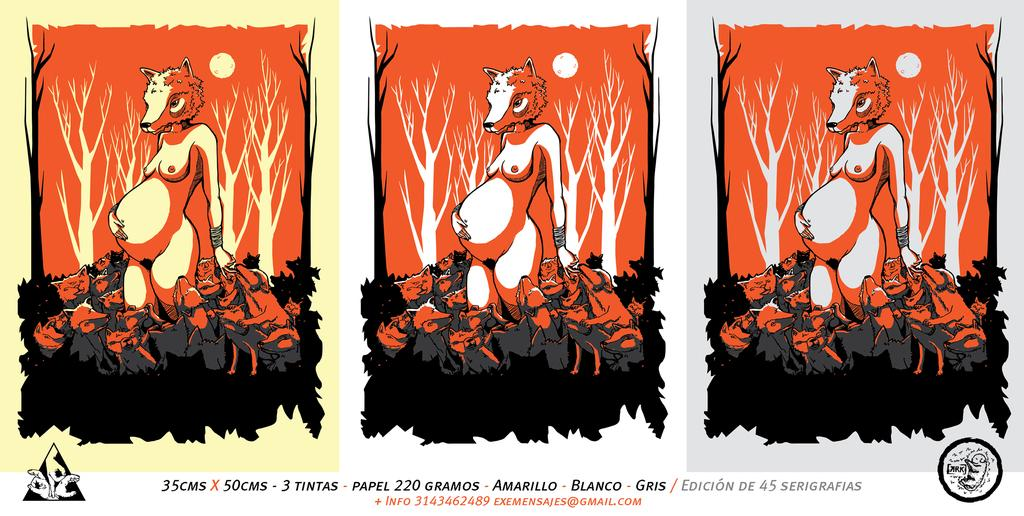<image>
Describe the image concisely. Poster that shows a pregnant animal and the words "Amarillo Blanco Gris" on the bottom. 